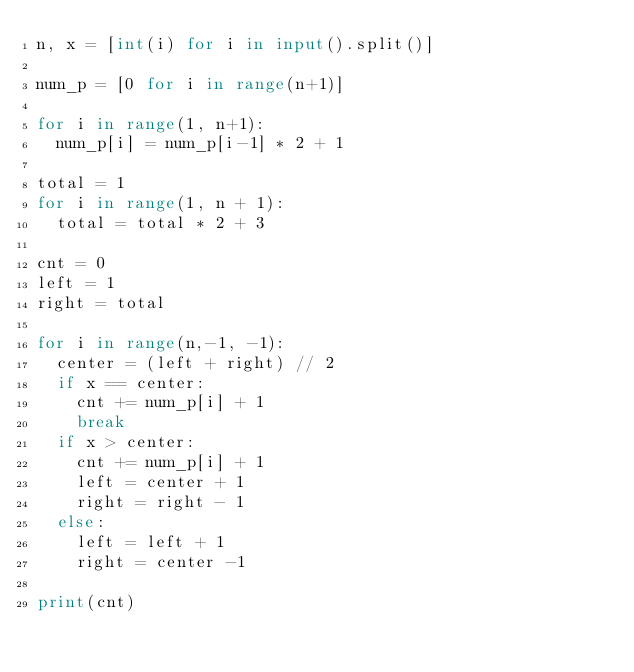Convert code to text. <code><loc_0><loc_0><loc_500><loc_500><_Python_>n, x = [int(i) for i in input().split()]

num_p = [0 for i in range(n+1)]

for i in range(1, n+1):
  num_p[i] = num_p[i-1] * 2 + 1

total = 1
for i in range(1, n + 1):
  total = total * 2 + 3

cnt = 0
left = 1
right = total

for i in range(n,-1, -1):
  center = (left + right) // 2
  if x == center:
    cnt += num_p[i] + 1
    break
  if x > center:
    cnt += num_p[i] + 1
    left = center + 1
    right = right - 1
  else:
    left = left + 1
    right = center -1

print(cnt)
</code> 